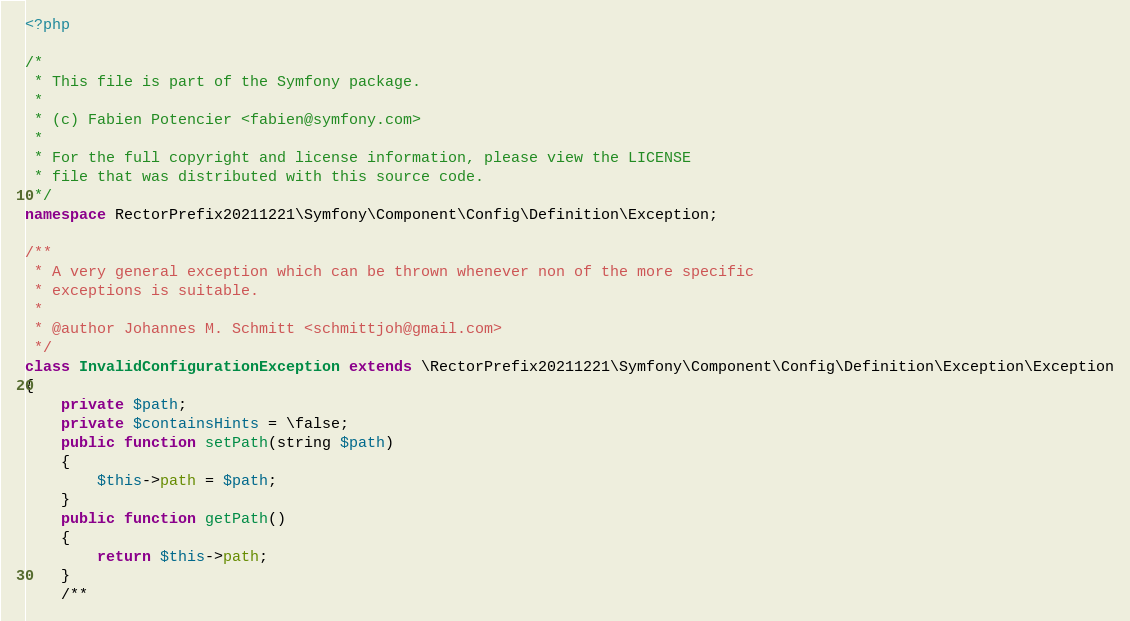Convert code to text. <code><loc_0><loc_0><loc_500><loc_500><_PHP_><?php

/*
 * This file is part of the Symfony package.
 *
 * (c) Fabien Potencier <fabien@symfony.com>
 *
 * For the full copyright and license information, please view the LICENSE
 * file that was distributed with this source code.
 */
namespace RectorPrefix20211221\Symfony\Component\Config\Definition\Exception;

/**
 * A very general exception which can be thrown whenever non of the more specific
 * exceptions is suitable.
 *
 * @author Johannes M. Schmitt <schmittjoh@gmail.com>
 */
class InvalidConfigurationException extends \RectorPrefix20211221\Symfony\Component\Config\Definition\Exception\Exception
{
    private $path;
    private $containsHints = \false;
    public function setPath(string $path)
    {
        $this->path = $path;
    }
    public function getPath()
    {
        return $this->path;
    }
    /**</code> 